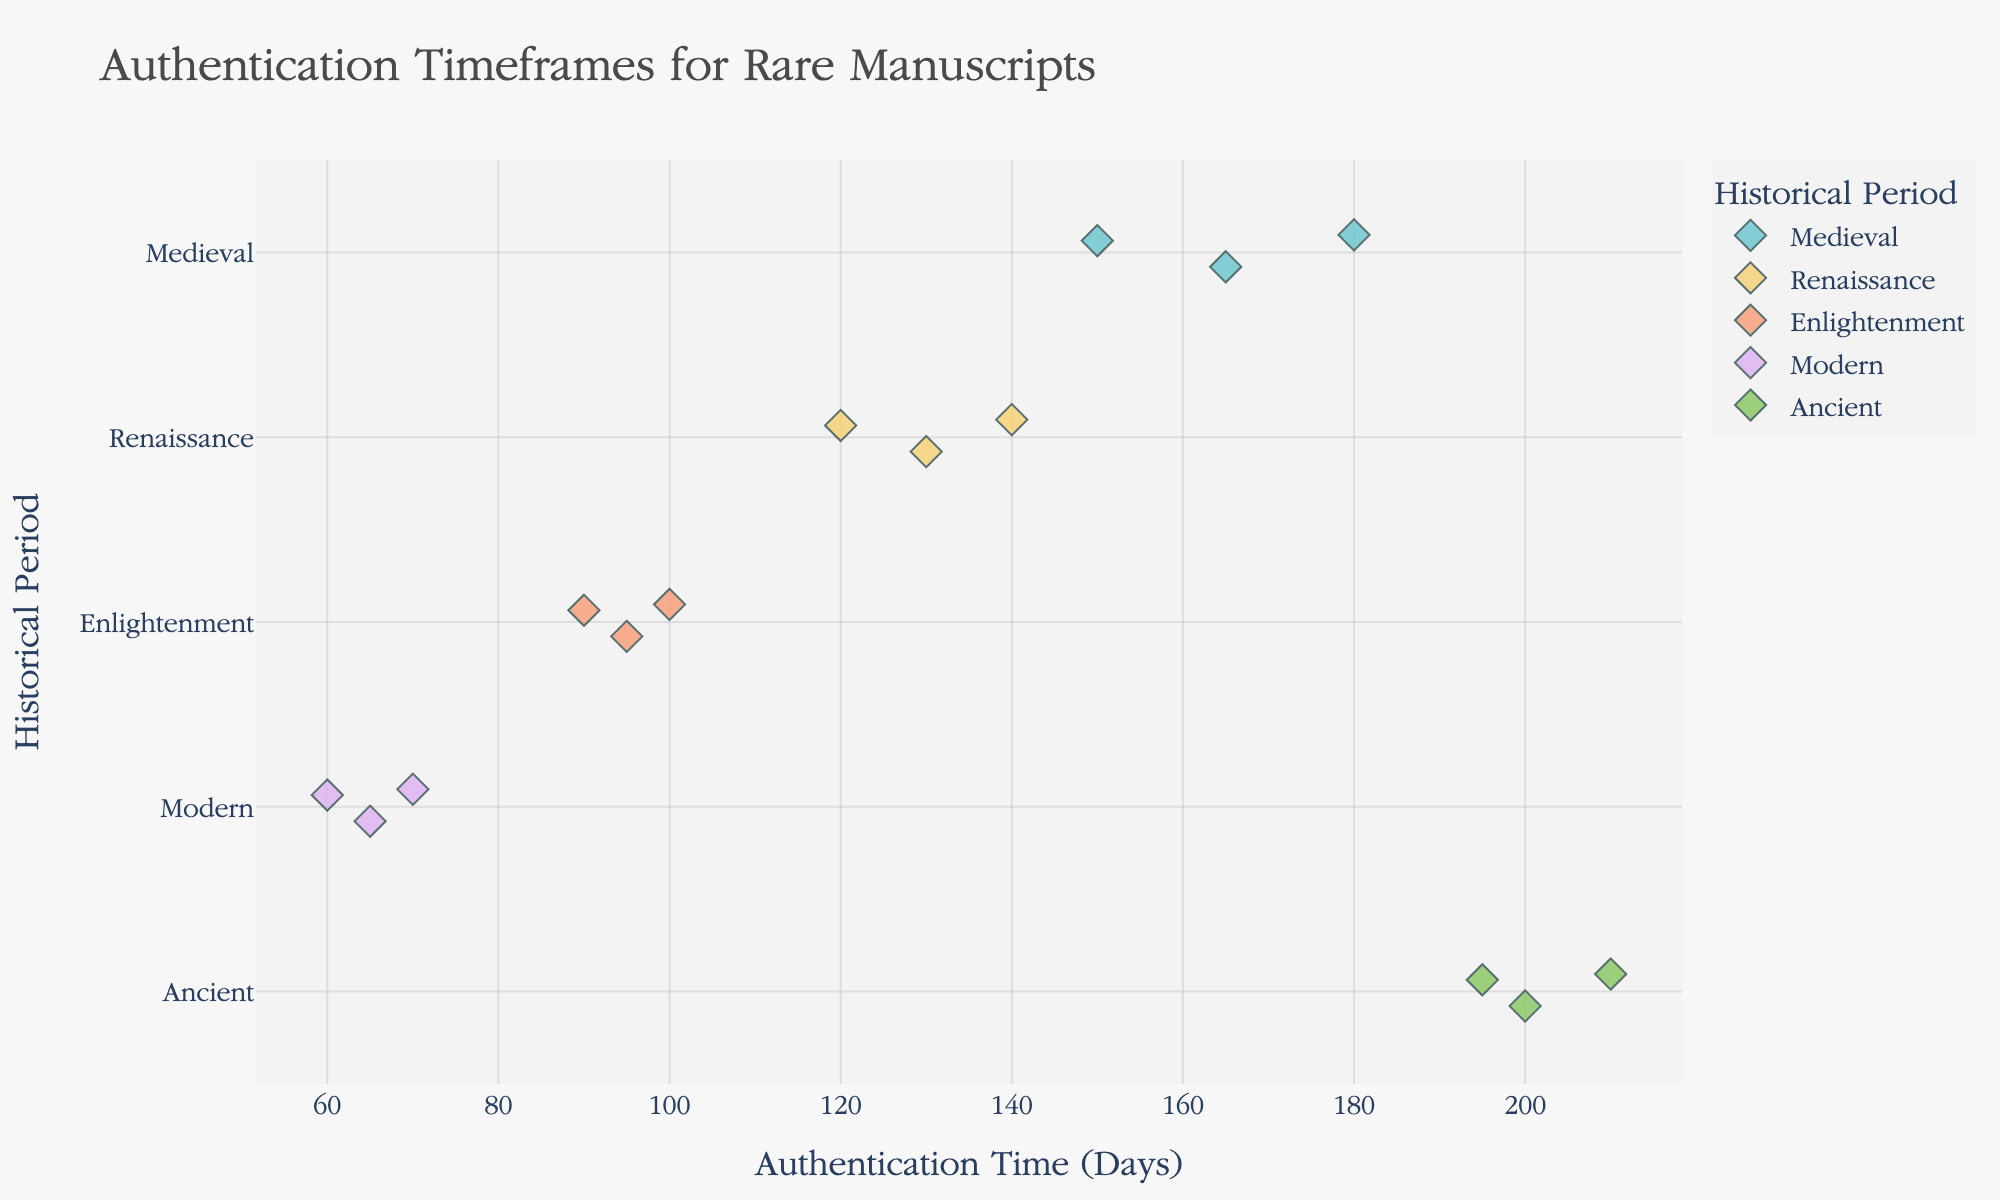What's the title of the figure? The title of the figure is usually displayed at the top of the plot. In this case, it is "Authentication Timeframes for Rare Manuscripts"
Answer: Authentication Timeframes for Rare Manuscripts Which historical period has the manuscript with the longest authentication time? Identify the manuscript with the highest value on the x-axis and observe its corresponding historical period on the y-axis. The "Dead Sea Scrolls" from "Ancient" period takes the longest time (210 days)
Answer: Ancient What is the average authentication time for manuscripts from the Renaissance period? Identify the data points for the Renaissance period and add their authentication times (120 + 140 + 130). Then, divide by the number of manuscripts (3). The calculation is (120 + 140 + 130) / 3 = 130
Answer: 130 Which manuscript from the Medieval period has the shortest authentication time? Among the Medieval manuscripts (Voynich Manuscript, Book of Kells, Lindisfarne Gospels), identify the one with the smallest x-axis value (Authentication Time). "Book of Kells" has the shortest time at 150 days
Answer: Book of Kells How many manuscripts are there from the Enlightenment period? Count the number of data points that correspond to the Enlightenment period on the y-axis. There are 3 data points for this period (The Birds of America, Encyclopédie, Principia Mathematica)
Answer: 3 Which historical period generally has the shortest authentication times? Compare the range of authentication times (x-axis values) for each historical period. The Modern period has the shortest range, with values between 60 and 70 days
Answer: Modern What is the difference in authentication time between the Voynich Manuscript and the Dead Sea Scrolls? Subtract the authentication time of the Voynich Manuscript from the Dead Sea Scrolls. The calculation is 210 - 180 = 30 days
Answer: 30 Are the authentication times for Enlightenment manuscripts generally shorter than those for Renaissance manuscripts? Compare the ranges of authentication times for both periods. Enlightenment manuscripts range from 90 to 100 days, while Renaissance manuscripts range from 120 to 140 days. Yes, Enlightenment manuscripts are generally shorter
Answer: Yes Which manuscript takes the second longest authentication time? Rank the manuscripts according to their authentication time and identify the second highest value. "Codex Sinaiticus" from the Ancient period takes 195 days, which is the second longest
Answer: Codex Sinaiticus Are there more manuscripts from the Medieval or Renaissance period? Count the number of data points for both periods. The Medieval period has 3 manuscripts (Voynich, Kells, Lindisfarne) and the Renaissance period also has 3 manuscripts (Codex Leicester, Très Riches Heures, Gutenberg). There are equal numbers of manuscripts from both periods
Answer: Equal 